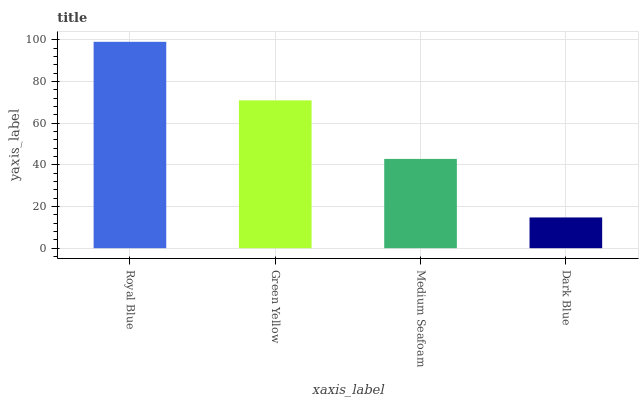Is Royal Blue the maximum?
Answer yes or no. Yes. Is Green Yellow the minimum?
Answer yes or no. No. Is Green Yellow the maximum?
Answer yes or no. No. Is Royal Blue greater than Green Yellow?
Answer yes or no. Yes. Is Green Yellow less than Royal Blue?
Answer yes or no. Yes. Is Green Yellow greater than Royal Blue?
Answer yes or no. No. Is Royal Blue less than Green Yellow?
Answer yes or no. No. Is Green Yellow the high median?
Answer yes or no. Yes. Is Medium Seafoam the low median?
Answer yes or no. Yes. Is Royal Blue the high median?
Answer yes or no. No. Is Dark Blue the low median?
Answer yes or no. No. 